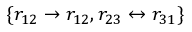Convert formula to latex. <formula><loc_0><loc_0><loc_500><loc_500>\{ r _ { 1 2 } \rightarrow r _ { 1 2 } , r _ { 2 3 } \leftrightarrow r _ { 3 1 } \}</formula> 